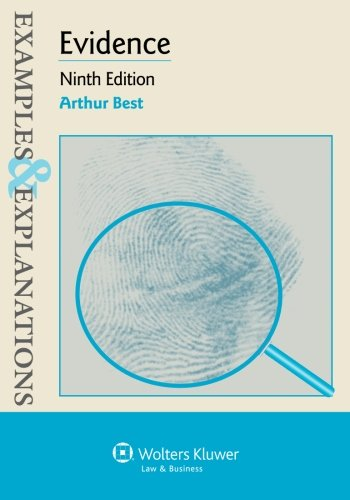Is this a judicial book? Yes, this is a judicial book, focusing on aspects of legal evidence, an essential component in legal studies and practice. 